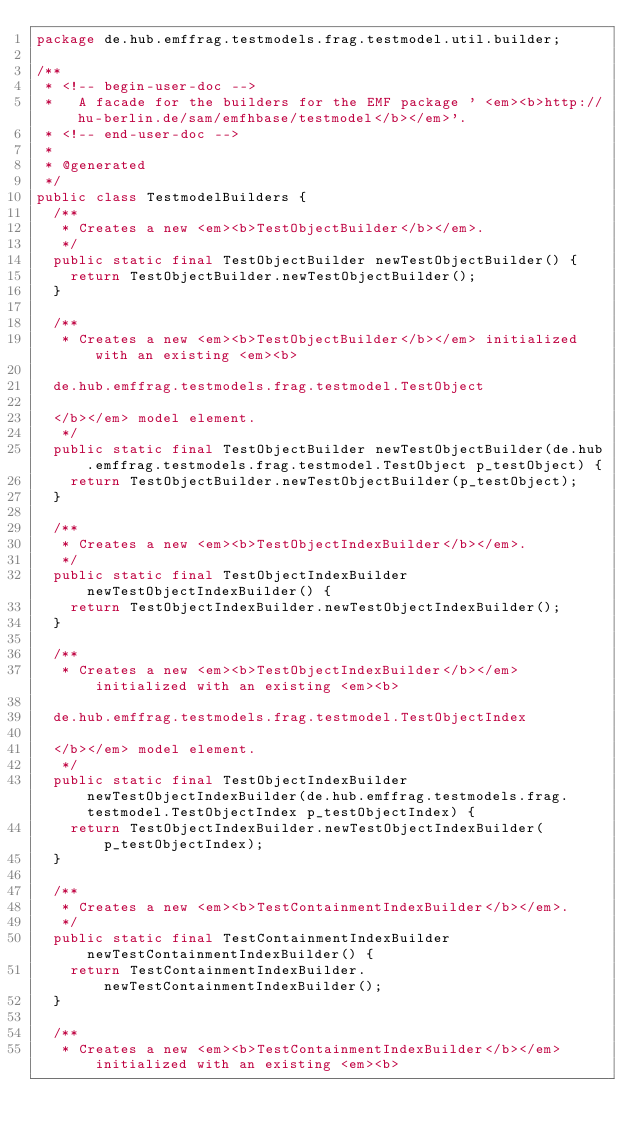<code> <loc_0><loc_0><loc_500><loc_500><_Java_>package de.hub.emffrag.testmodels.frag.testmodel.util.builder;

/**
 * <!-- begin-user-doc --> 
 *   A facade for the builders for the EMF package ' <em><b>http://hu-berlin.de/sam/emfhbase/testmodel</b></em>'.
 * <!-- end-user-doc -->
 * 
 * @generated
 */
public class TestmodelBuilders {
  /**
   * Creates a new <em><b>TestObjectBuilder</b></em>.
   */
  public static final TestObjectBuilder newTestObjectBuilder() {
    return TestObjectBuilder.newTestObjectBuilder();
  }

  /**
   * Creates a new <em><b>TestObjectBuilder</b></em> initialized with an existing <em><b>  
  
  de.hub.emffrag.testmodels.frag.testmodel.TestObject
  
  </b></em> model element.
   */
  public static final TestObjectBuilder newTestObjectBuilder(de.hub.emffrag.testmodels.frag.testmodel.TestObject p_testObject) {
    return TestObjectBuilder.newTestObjectBuilder(p_testObject);
  }

  /**
   * Creates a new <em><b>TestObjectIndexBuilder</b></em>.
   */
  public static final TestObjectIndexBuilder newTestObjectIndexBuilder() {
    return TestObjectIndexBuilder.newTestObjectIndexBuilder();
  }

  /**
   * Creates a new <em><b>TestObjectIndexBuilder</b></em> initialized with an existing <em><b>  
  
  de.hub.emffrag.testmodels.frag.testmodel.TestObjectIndex
  
  </b></em> model element.
   */
  public static final TestObjectIndexBuilder newTestObjectIndexBuilder(de.hub.emffrag.testmodels.frag.testmodel.TestObjectIndex p_testObjectIndex) {
    return TestObjectIndexBuilder.newTestObjectIndexBuilder(p_testObjectIndex);
  }

  /**
   * Creates a new <em><b>TestContainmentIndexBuilder</b></em>.
   */
  public static final TestContainmentIndexBuilder newTestContainmentIndexBuilder() {
    return TestContainmentIndexBuilder.newTestContainmentIndexBuilder();
  }

  /**
   * Creates a new <em><b>TestContainmentIndexBuilder</b></em> initialized with an existing <em><b>  
  </code> 